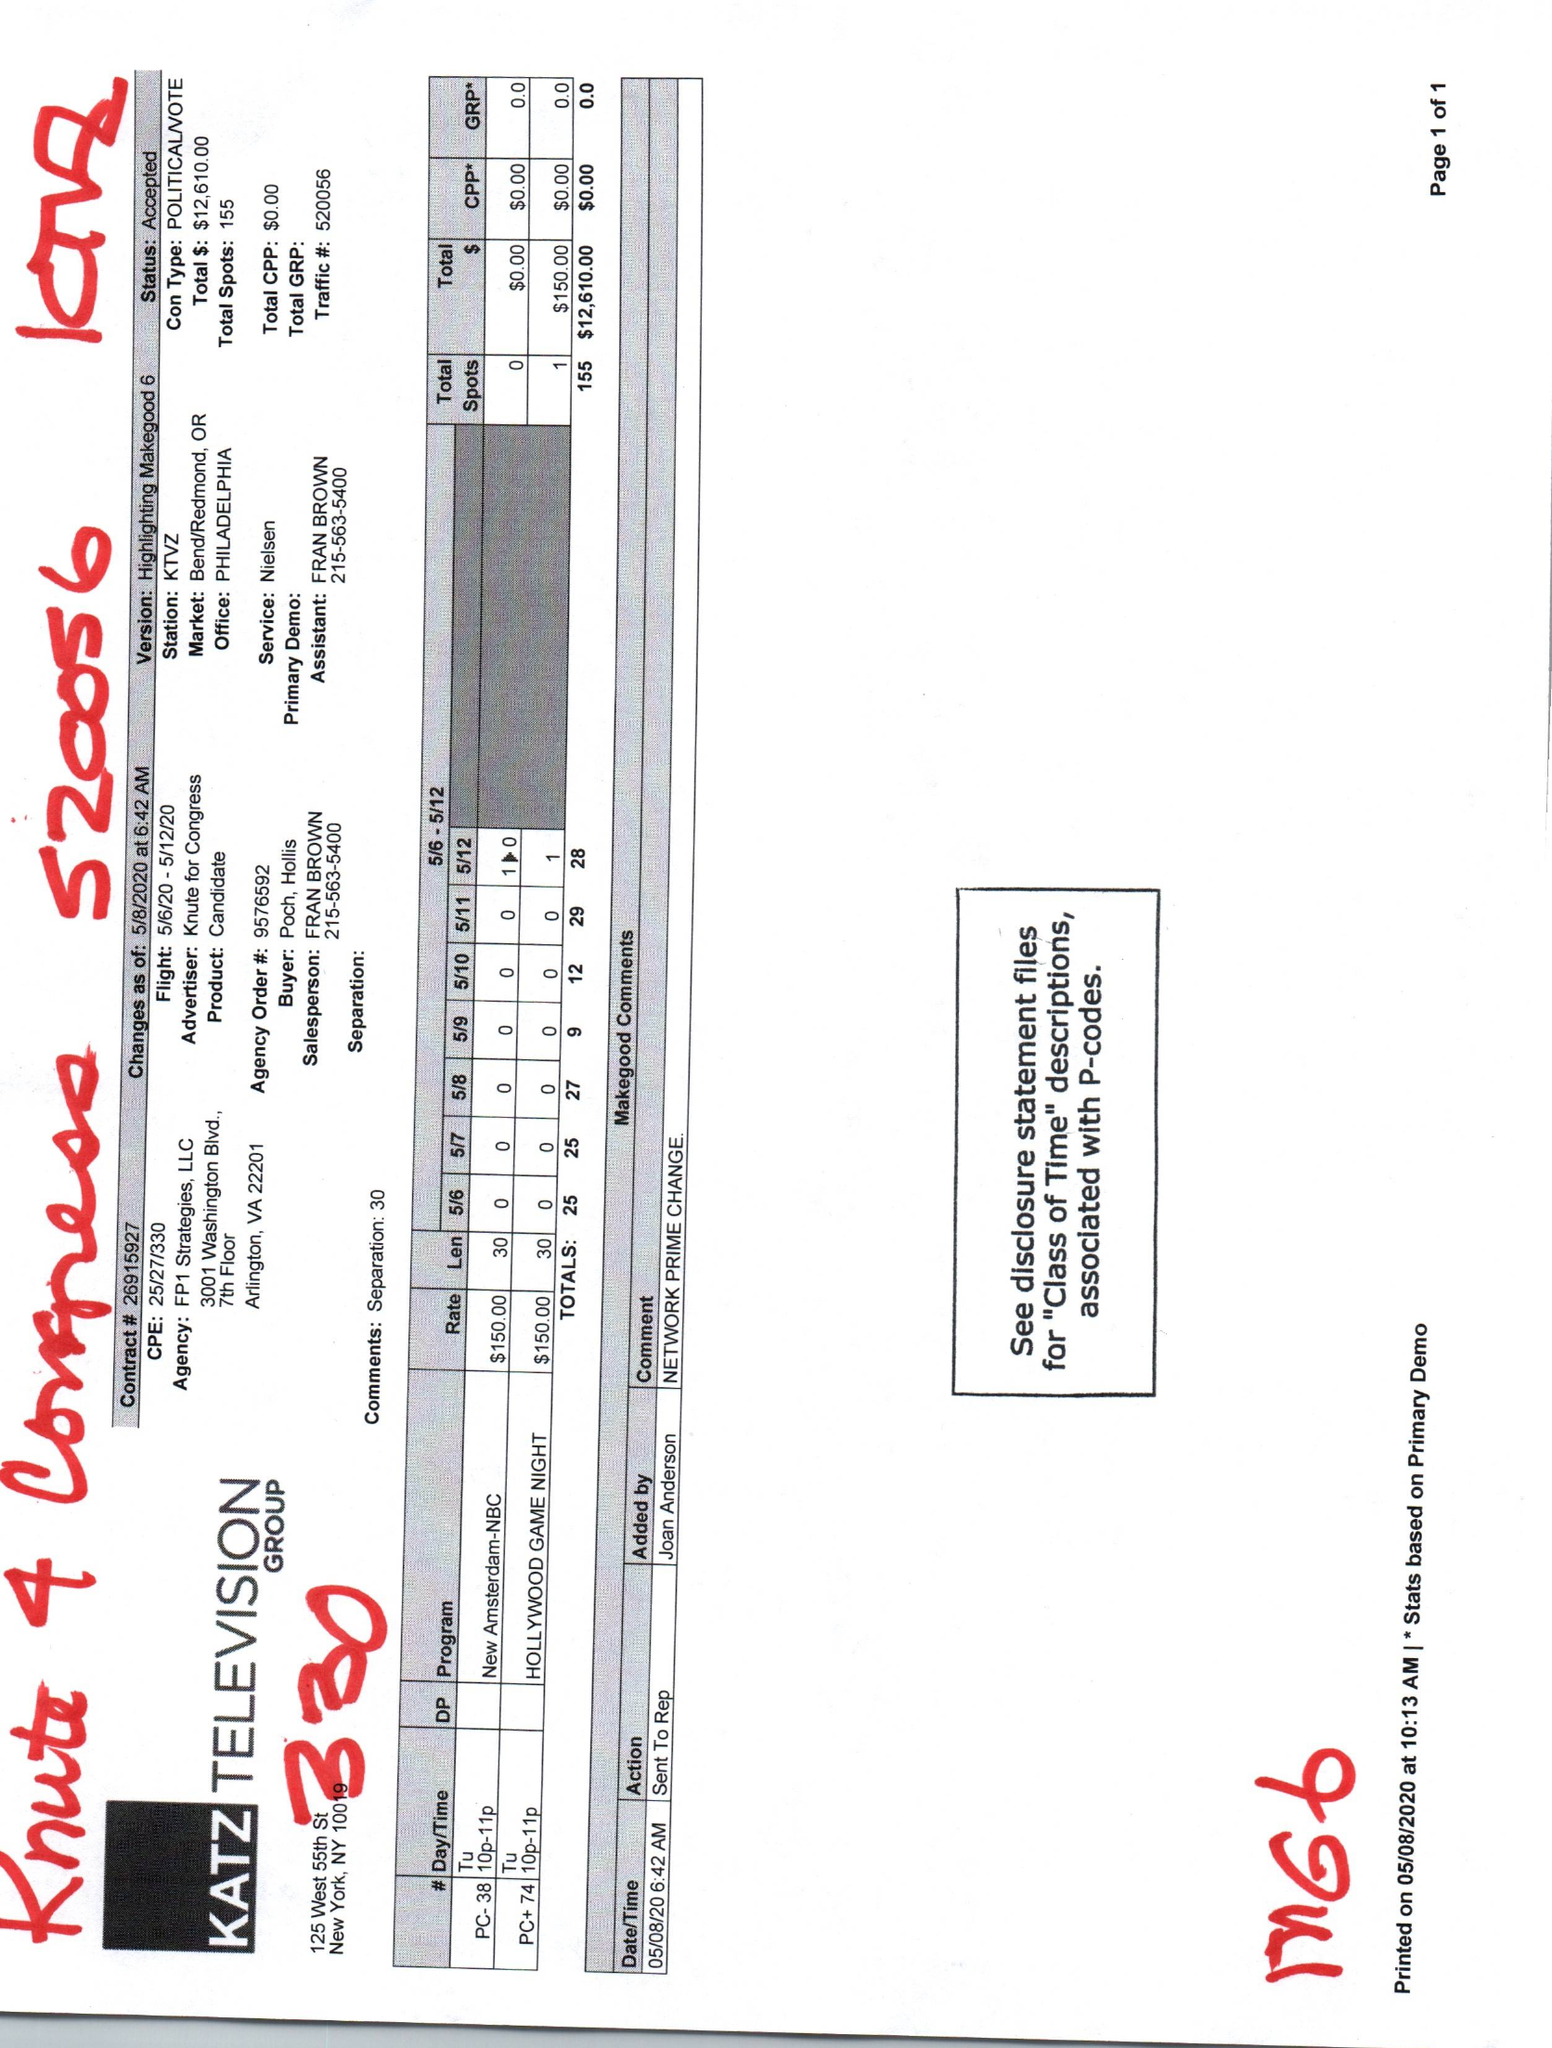What is the value for the flight_to?
Answer the question using a single word or phrase. 05/12/20 